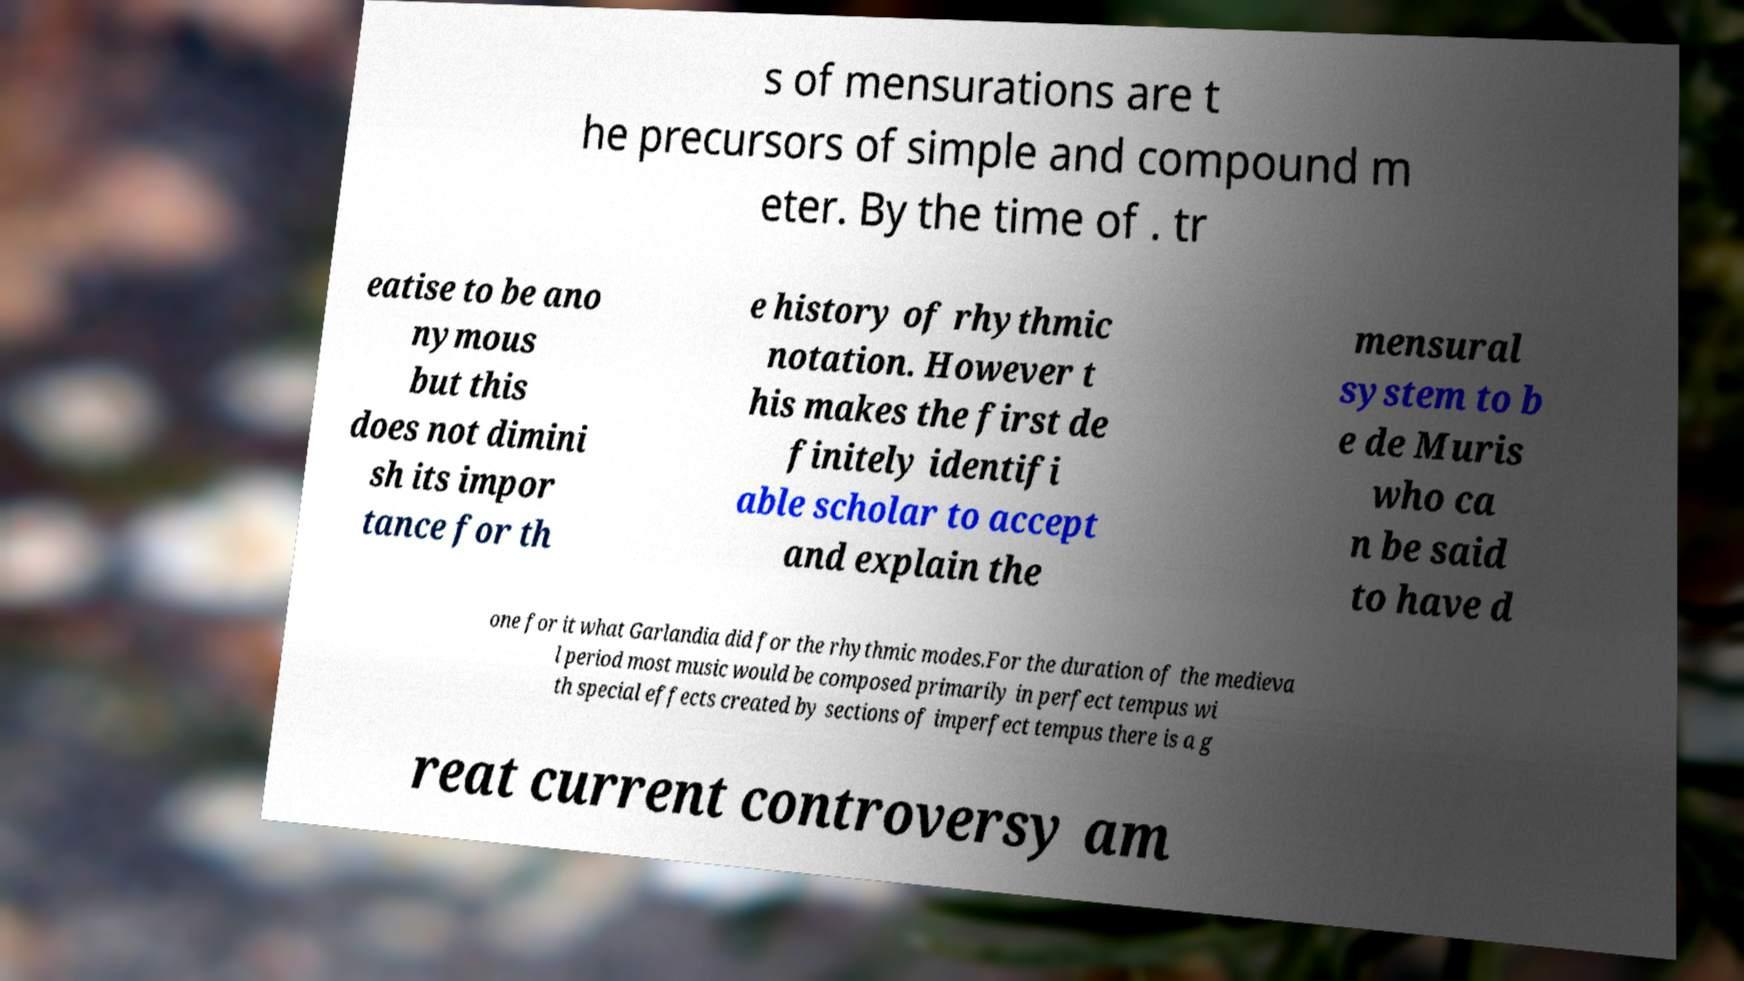Please read and relay the text visible in this image. What does it say? s of mensurations are t he precursors of simple and compound m eter. By the time of . tr eatise to be ano nymous but this does not dimini sh its impor tance for th e history of rhythmic notation. However t his makes the first de finitely identifi able scholar to accept and explain the mensural system to b e de Muris who ca n be said to have d one for it what Garlandia did for the rhythmic modes.For the duration of the medieva l period most music would be composed primarily in perfect tempus wi th special effects created by sections of imperfect tempus there is a g reat current controversy am 